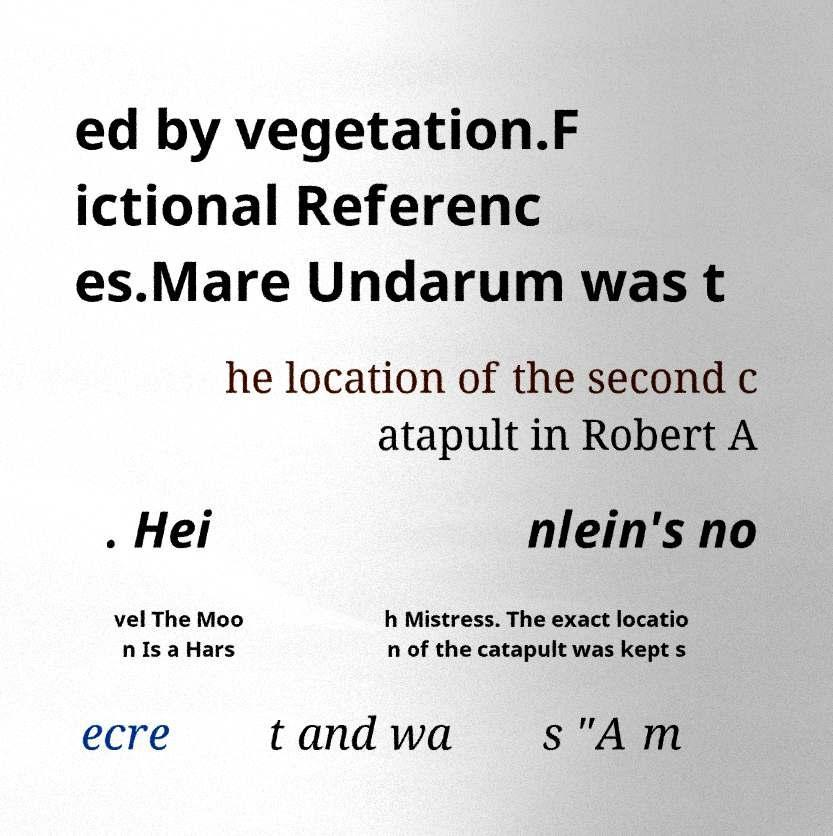Could you assist in decoding the text presented in this image and type it out clearly? ed by vegetation.F ictional Referenc es.Mare Undarum was t he location of the second c atapult in Robert A . Hei nlein's no vel The Moo n Is a Hars h Mistress. The exact locatio n of the catapult was kept s ecre t and wa s "A m 